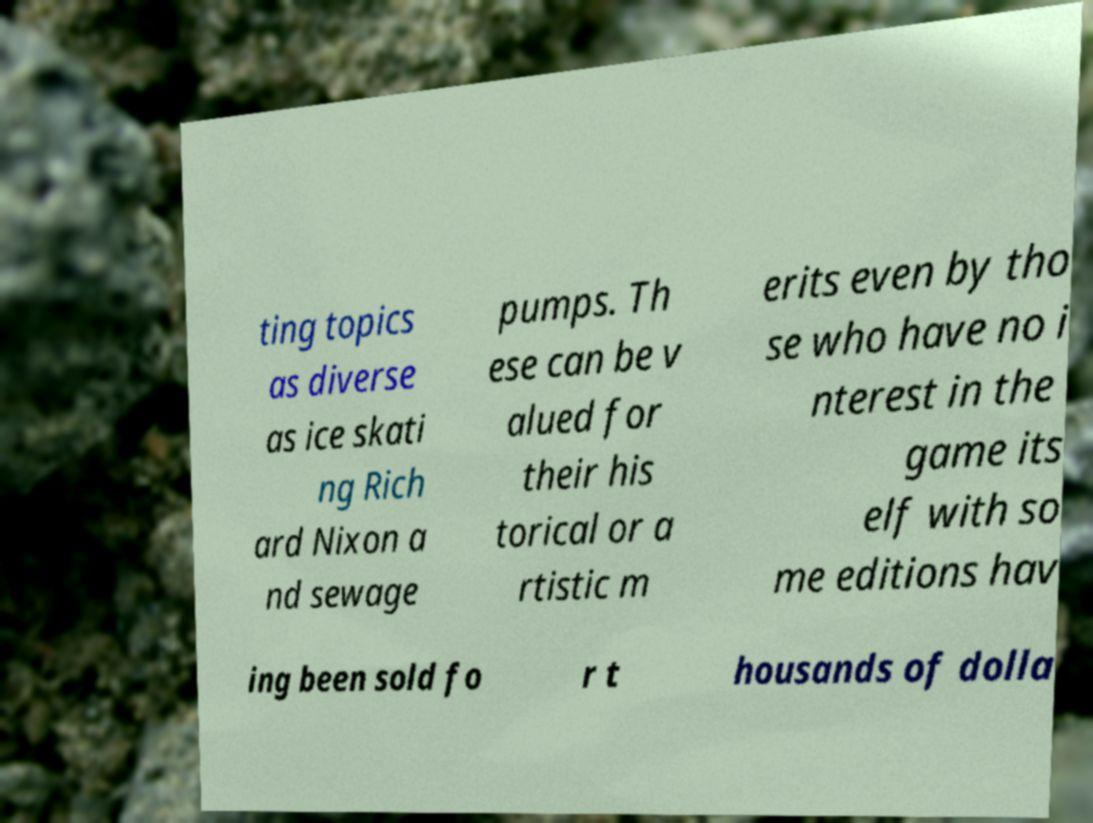There's text embedded in this image that I need extracted. Can you transcribe it verbatim? ting topics as diverse as ice skati ng Rich ard Nixon a nd sewage pumps. Th ese can be v alued for their his torical or a rtistic m erits even by tho se who have no i nterest in the game its elf with so me editions hav ing been sold fo r t housands of dolla 